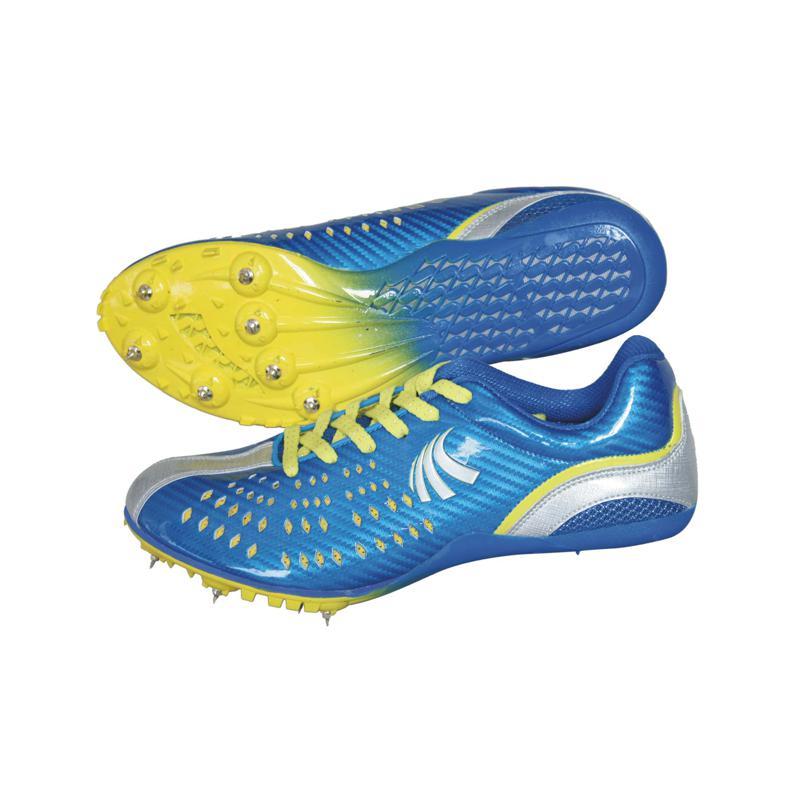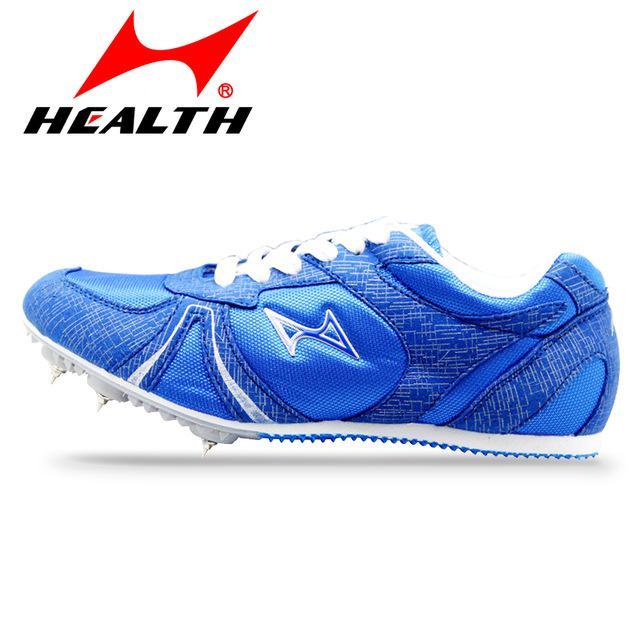The first image is the image on the left, the second image is the image on the right. For the images shown, is this caption "One image contains a single, mostly blue shoe, and the other image shows a pair of shoes, one with its sole turned to the camera." true? Answer yes or no. Yes. The first image is the image on the left, the second image is the image on the right. Analyze the images presented: Is the assertion "The right image contains exactly one blue sports tennis shoe." valid? Answer yes or no. Yes. 